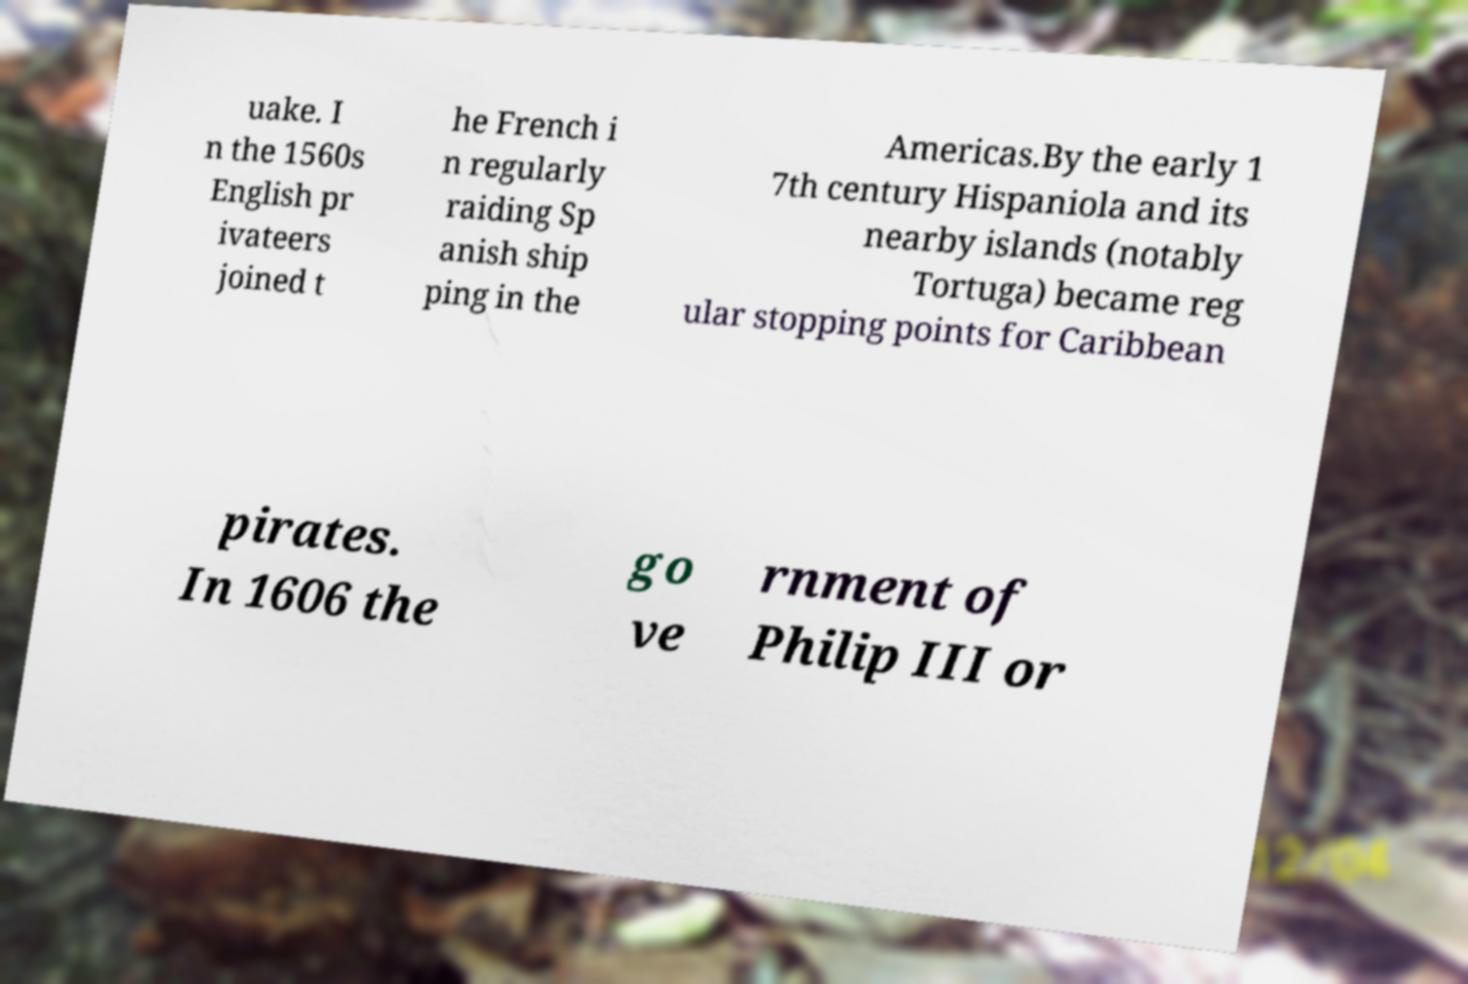Please read and relay the text visible in this image. What does it say? uake. I n the 1560s English pr ivateers joined t he French i n regularly raiding Sp anish ship ping in the Americas.By the early 1 7th century Hispaniola and its nearby islands (notably Tortuga) became reg ular stopping points for Caribbean pirates. In 1606 the go ve rnment of Philip III or 